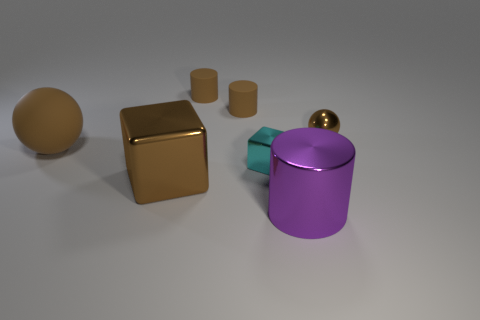Is there any other thing that has the same shape as the cyan metal thing?
Ensure brevity in your answer.  Yes. The big object right of the big brown cube has what shape?
Provide a succinct answer. Cylinder. How many purple metallic things have the same shape as the large rubber object?
Your response must be concise. 0. There is a big metal thing behind the large purple shiny cylinder; is its color the same as the big object that is on the right side of the big brown cube?
Keep it short and to the point. No. How many objects are large gray cubes or rubber cylinders?
Your response must be concise. 2. What number of tiny cyan blocks have the same material as the cyan thing?
Offer a terse response. 0. Are there fewer small cyan cylinders than small cyan metallic things?
Your answer should be compact. Yes. Does the cylinder in front of the brown rubber sphere have the same material as the large ball?
Keep it short and to the point. No. How many cubes are green rubber things or small cyan metallic things?
Your answer should be compact. 1. What shape is the shiny thing that is both in front of the tiny block and right of the small cyan block?
Ensure brevity in your answer.  Cylinder. 